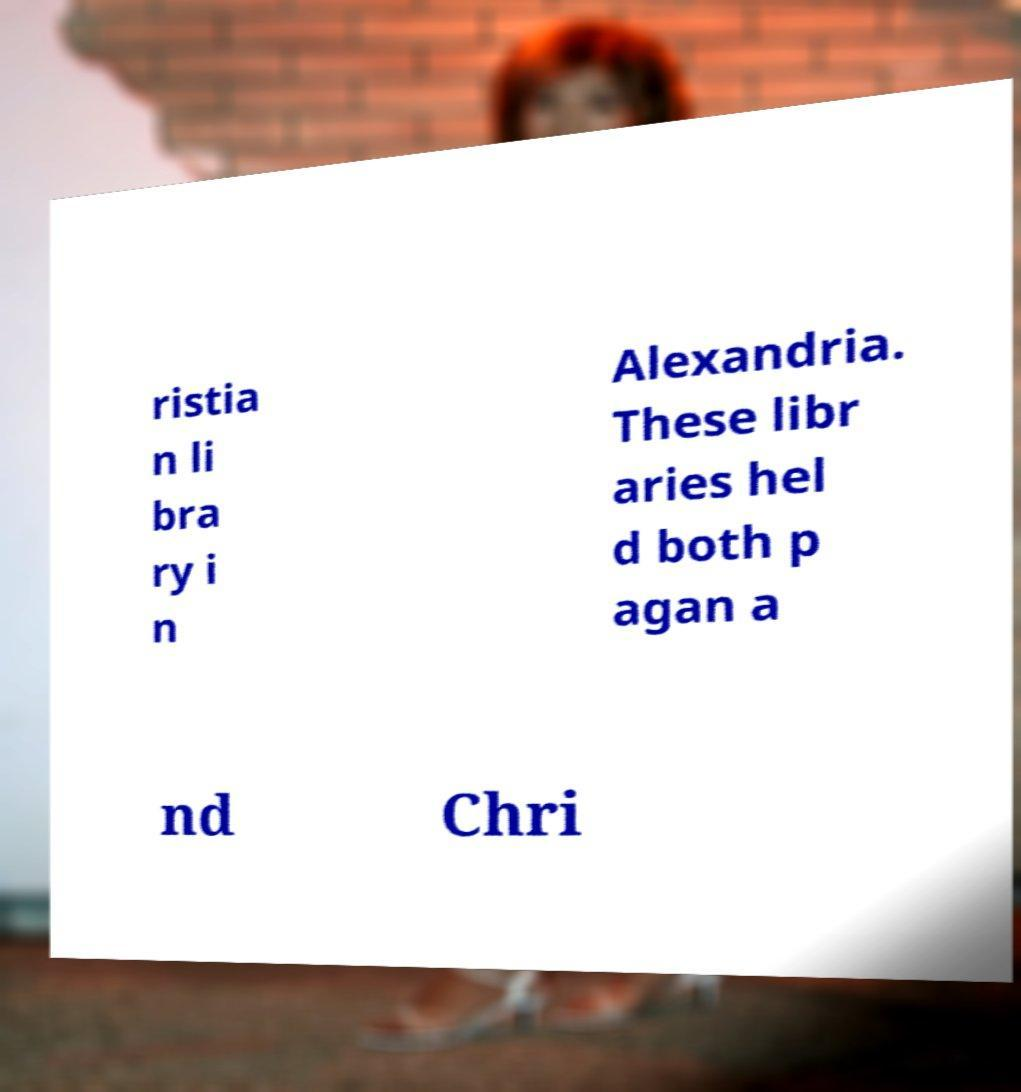Could you assist in decoding the text presented in this image and type it out clearly? ristia n li bra ry i n Alexandria. These libr aries hel d both p agan a nd Chri 